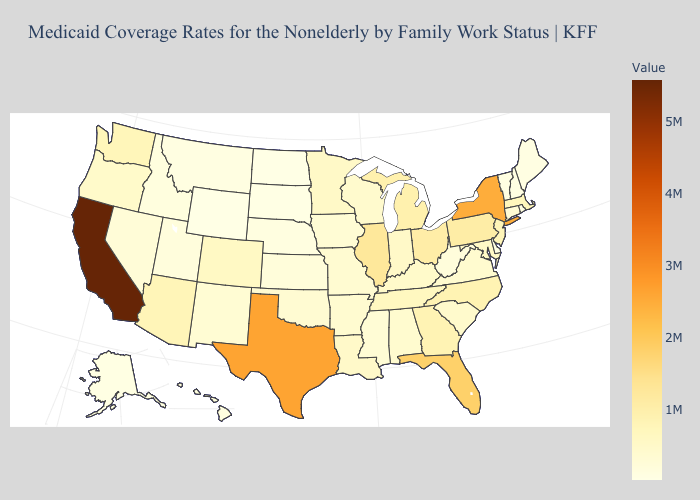Which states have the highest value in the USA?
Answer briefly. California. Is the legend a continuous bar?
Quick response, please. Yes. Does Texas have the highest value in the South?
Short answer required. Yes. Among the states that border Florida , which have the lowest value?
Concise answer only. Alabama. Among the states that border Idaho , which have the highest value?
Write a very short answer. Washington. 